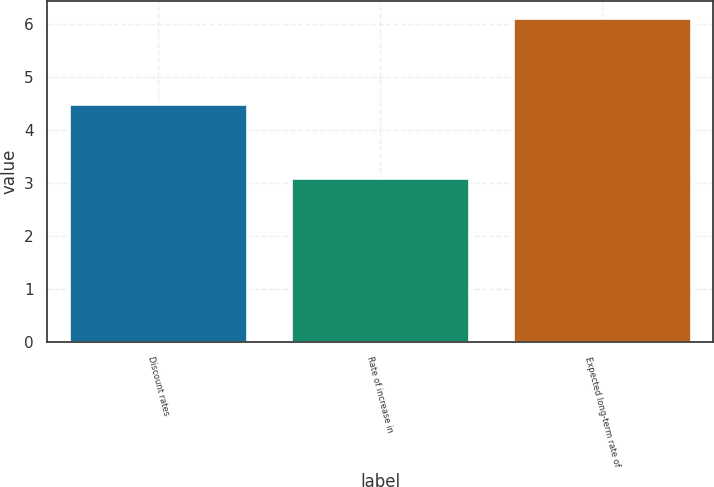Convert chart to OTSL. <chart><loc_0><loc_0><loc_500><loc_500><bar_chart><fcel>Discount rates<fcel>Rate of increase in<fcel>Expected long-term rate of<nl><fcel>4.5<fcel>3.1<fcel>6.13<nl></chart> 